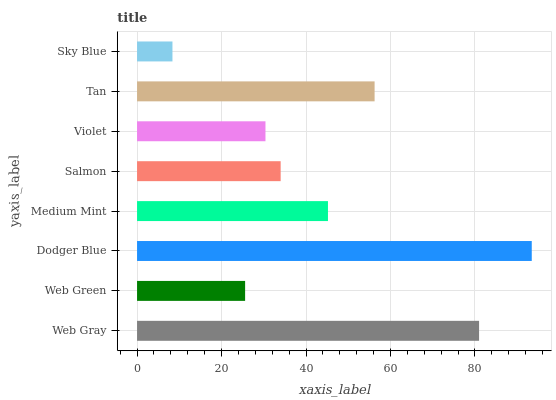Is Sky Blue the minimum?
Answer yes or no. Yes. Is Dodger Blue the maximum?
Answer yes or no. Yes. Is Web Green the minimum?
Answer yes or no. No. Is Web Green the maximum?
Answer yes or no. No. Is Web Gray greater than Web Green?
Answer yes or no. Yes. Is Web Green less than Web Gray?
Answer yes or no. Yes. Is Web Green greater than Web Gray?
Answer yes or no. No. Is Web Gray less than Web Green?
Answer yes or no. No. Is Medium Mint the high median?
Answer yes or no. Yes. Is Salmon the low median?
Answer yes or no. Yes. Is Dodger Blue the high median?
Answer yes or no. No. Is Violet the low median?
Answer yes or no. No. 